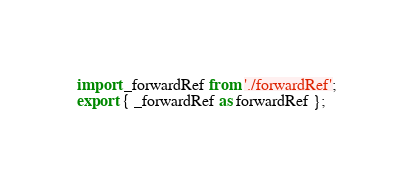<code> <loc_0><loc_0><loc_500><loc_500><_JavaScript_>import _forwardRef from './forwardRef';
export { _forwardRef as forwardRef };</code> 